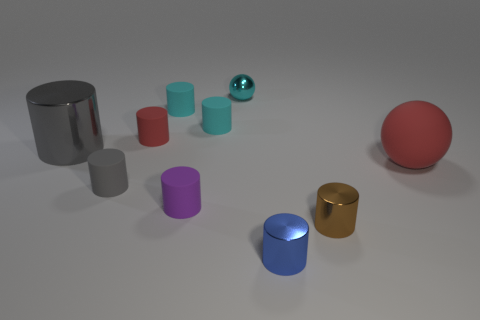Subtract all balls. How many objects are left? 8 Subtract 6 cylinders. How many cylinders are left? 2 Subtract all cyan balls. How many balls are left? 1 Subtract all purple rubber cylinders. How many cylinders are left? 7 Subtract 0 green balls. How many objects are left? 10 Subtract all cyan spheres. Subtract all gray blocks. How many spheres are left? 1 Subtract all gray cylinders. How many cyan spheres are left? 1 Subtract all shiny objects. Subtract all small cyan rubber spheres. How many objects are left? 6 Add 2 tiny red rubber objects. How many tiny red rubber objects are left? 3 Add 8 large gray metallic things. How many large gray metallic things exist? 9 